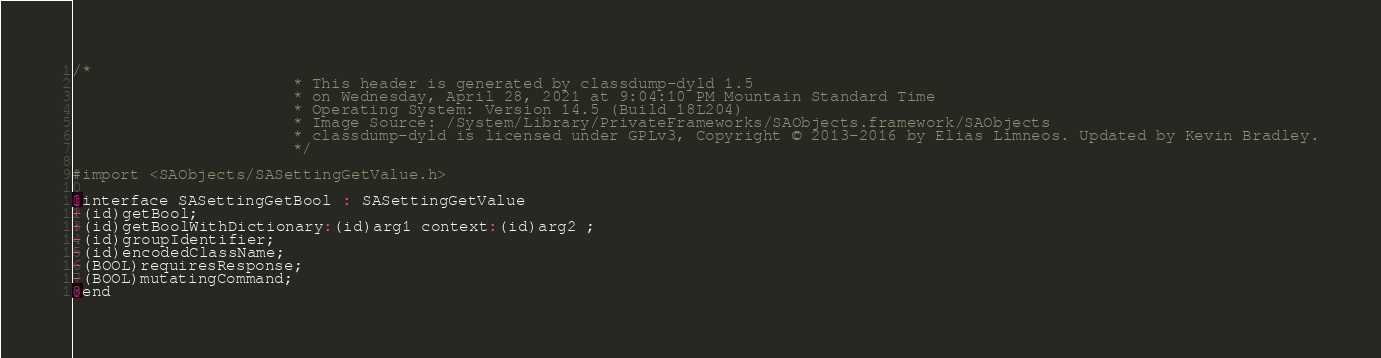<code> <loc_0><loc_0><loc_500><loc_500><_C_>/*
                       * This header is generated by classdump-dyld 1.5
                       * on Wednesday, April 28, 2021 at 9:04:10 PM Mountain Standard Time
                       * Operating System: Version 14.5 (Build 18L204)
                       * Image Source: /System/Library/PrivateFrameworks/SAObjects.framework/SAObjects
                       * classdump-dyld is licensed under GPLv3, Copyright © 2013-2016 by Elias Limneos. Updated by Kevin Bradley.
                       */

#import <SAObjects/SASettingGetValue.h>

@interface SASettingGetBool : SASettingGetValue
+(id)getBool;
+(id)getBoolWithDictionary:(id)arg1 context:(id)arg2 ;
-(id)groupIdentifier;
-(id)encodedClassName;
-(BOOL)requiresResponse;
-(BOOL)mutatingCommand;
@end

</code> 